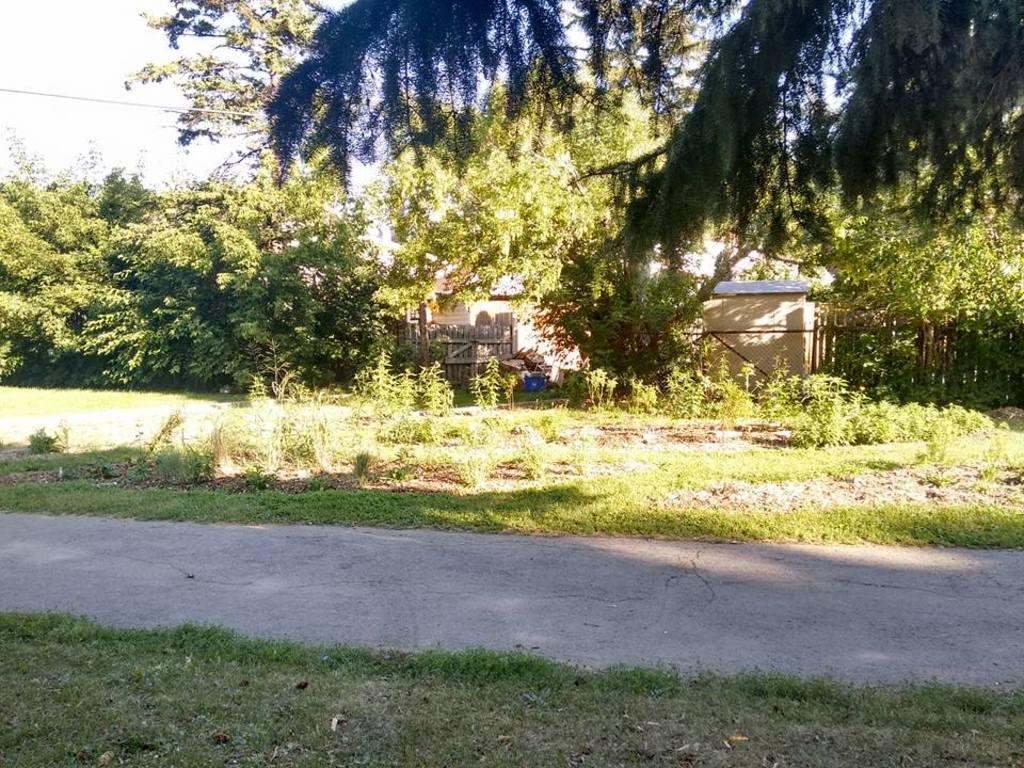What can be seen in the foreground of the image? There is a path in the foreground of the image. What type of vegetation is present alongside the path? Grass is present on either side of the path. What structures can be seen in the background of the image? There are houses in the background of the image. What else is visible in the background of the image? Trees and the sky are visible in the background of the image. Can you tell me how many tomatoes are growing on the trees in the image? There are no tomatoes visible in the image; only trees are present. What type of expert is shown giving a lecture in the image? There is no expert or lecture present in the image. 